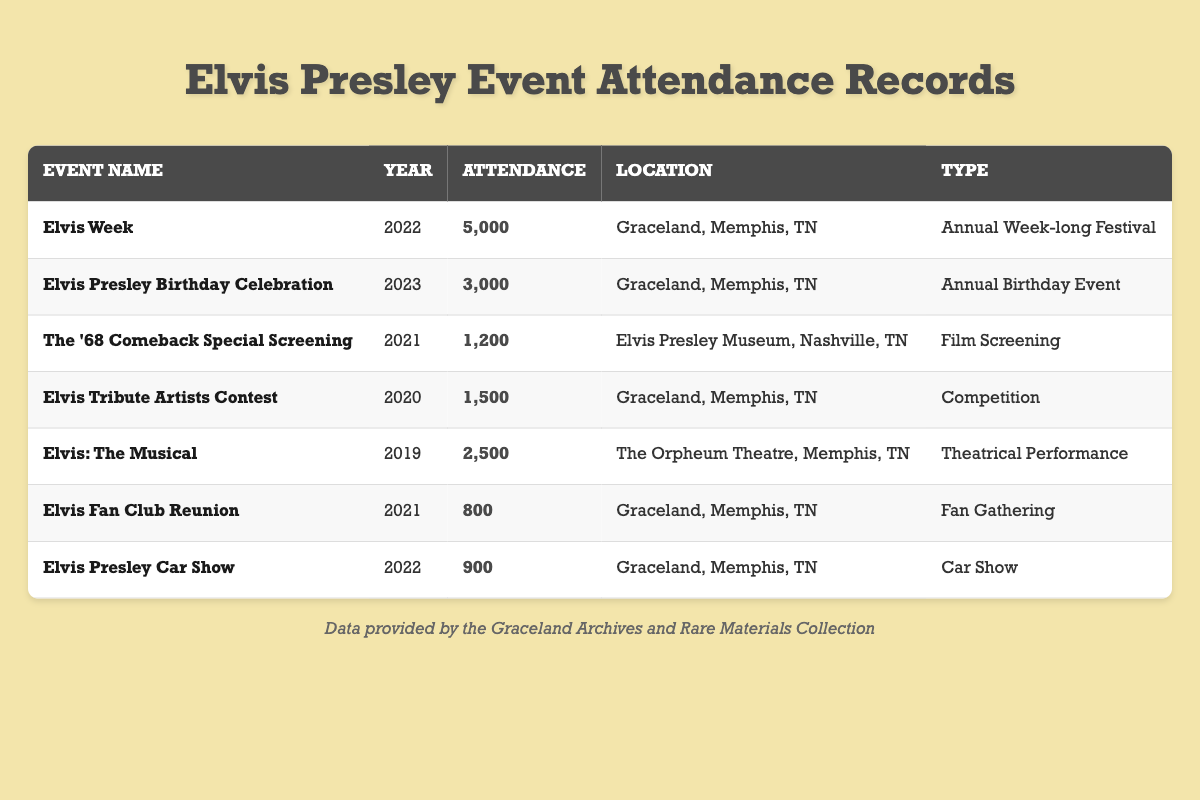What was the attendance for the Elvis Week event in 2022? The table shows that for the event "Elvis Week" in the year 2022, the attendance was listed as 5000.
Answer: 5000 How many attendees were at the Elvis Presley Birthday Celebration in 2023? According to the table, the attendance for the "Elvis Presley Birthday Celebration" in 2023 is recorded as 3000.
Answer: 3000 What is the total attendance for all events held in 2022? The events in 2022 are "Elvis Week" with an attendance of 5000 and "Elvis Presley Car Show" with 900. Adding these gives us 5000 + 900 = 5900.
Answer: 5900 Did more people attend the Elvis Tribute Artists Contest in 2020 compared to the Elvis Fan Club Reunion in 2021? The attendance for the "Elvis Tribute Artists Contest" in 2020 was 1500, while the "Elvis Fan Club Reunion" in 2021 had 800 attendees. Since 1500 is greater than 800, the answer is yes.
Answer: Yes What was the average attendance across all events listed in the table? To find the average attendance, we first sum all attendance numbers: 5000 + 3000 + 1200 + 1500 + 2500 + 800 + 900 = 13900. There are 7 events listed, so the average attendance is 13900 / 7 ≈ 1985.71.
Answer: 1985.71 Which event had the lowest attendance? The lowest attendance was for the "Elvis Fan Club Reunion" in 2021, which had 800 attendees, making it less than any other event listed.
Answer: Elvis Fan Club Reunion How many events were held in Graceland, Memphis, TN? By reviewing the table, we can see that the events held at Graceland, Memphis, TN include "Elvis Week," "Elvis Tribute Artists Contest," "Elvis Presley Car Show," and "Elvis Presley Birthday Celebration." That's a total of four events.
Answer: 4 What types of events had more than 2000 attendees? Upon reviewing the table, "Elvis Week" (5000) and "Elvis Presley Birthday Celebration" (3000) are the only events with attendance greater than 2000.
Answer: Elvis Week, Elvis Presley Birthday Celebration 